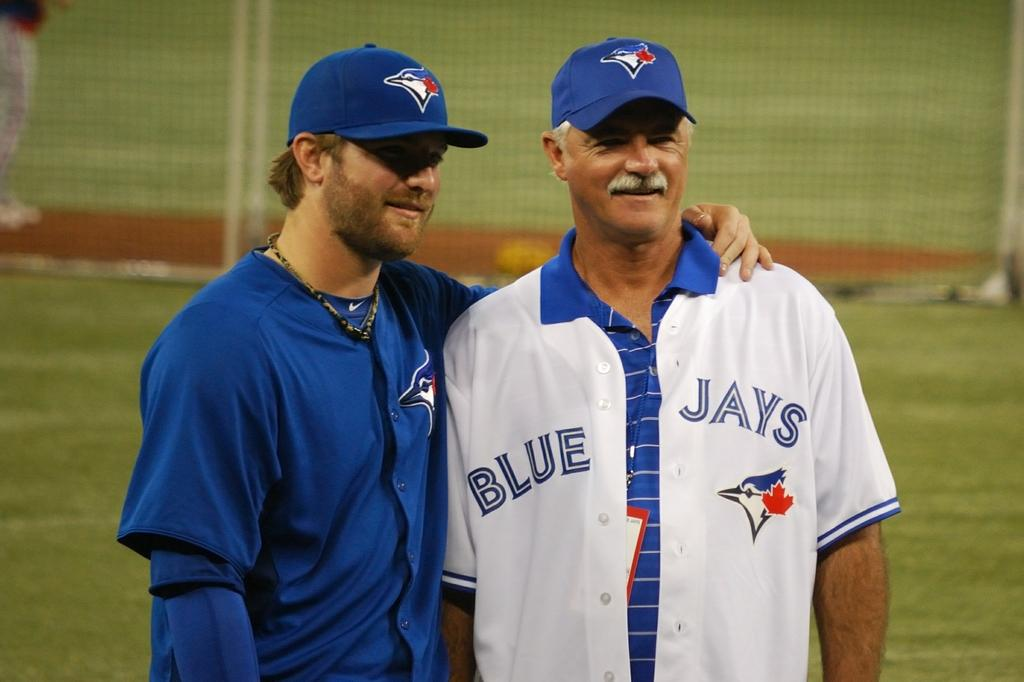<image>
Offer a succinct explanation of the picture presented. Two men in Blue Jays outfits stand together. 